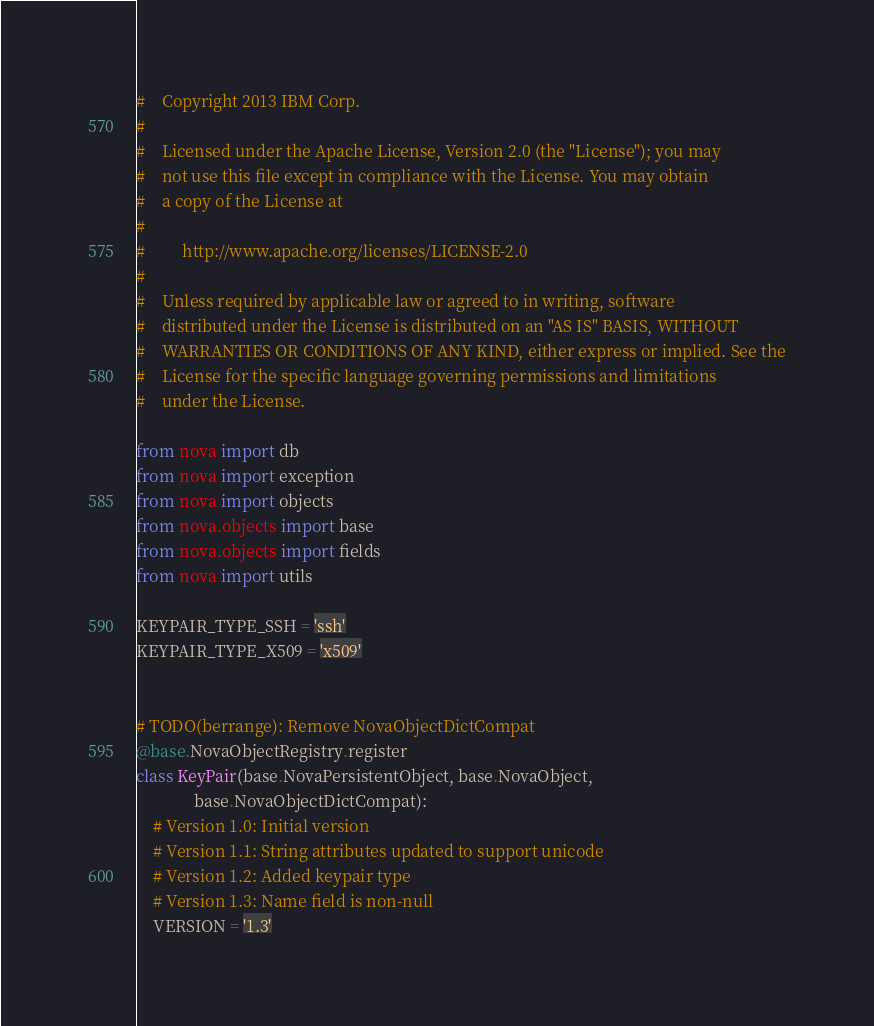<code> <loc_0><loc_0><loc_500><loc_500><_Python_>#    Copyright 2013 IBM Corp.
#
#    Licensed under the Apache License, Version 2.0 (the "License"); you may
#    not use this file except in compliance with the License. You may obtain
#    a copy of the License at
#
#         http://www.apache.org/licenses/LICENSE-2.0
#
#    Unless required by applicable law or agreed to in writing, software
#    distributed under the License is distributed on an "AS IS" BASIS, WITHOUT
#    WARRANTIES OR CONDITIONS OF ANY KIND, either express or implied. See the
#    License for the specific language governing permissions and limitations
#    under the License.

from nova import db
from nova import exception
from nova import objects
from nova.objects import base
from nova.objects import fields
from nova import utils

KEYPAIR_TYPE_SSH = 'ssh'
KEYPAIR_TYPE_X509 = 'x509'


# TODO(berrange): Remove NovaObjectDictCompat
@base.NovaObjectRegistry.register
class KeyPair(base.NovaPersistentObject, base.NovaObject,
              base.NovaObjectDictCompat):
    # Version 1.0: Initial version
    # Version 1.1: String attributes updated to support unicode
    # Version 1.2: Added keypair type
    # Version 1.3: Name field is non-null
    VERSION = '1.3'
</code> 